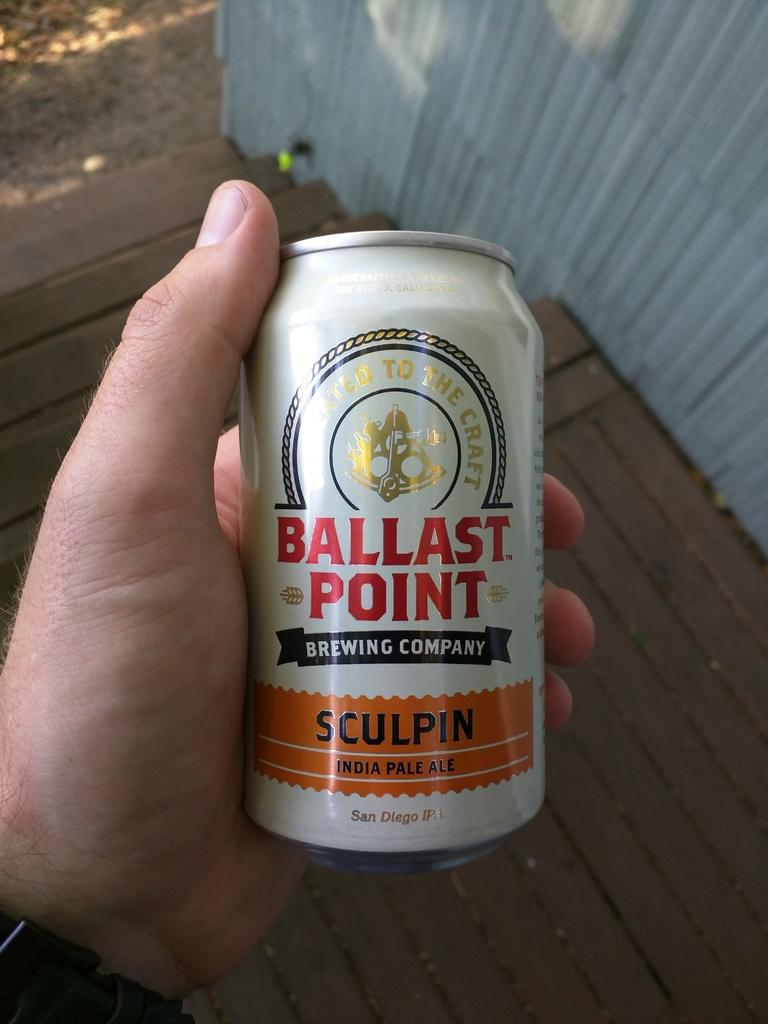What can be seen in the person's hand in the image? There is a tin in the person's hand in the image. What is written or printed on the tin? There is text on the tin. What type of surface is visible beneath the person's feet in the image? There is a wooden floor visible in the image. What is the background of the image made of? There is a wall visible in the image. Can you see a crown on the person's head in the image? There is no crown visible on the person's head in the image. What type of cracker is being held in the person's hand along with the tin? There is no cracker present in the image; only the person's hand holding a tin can be seen. 